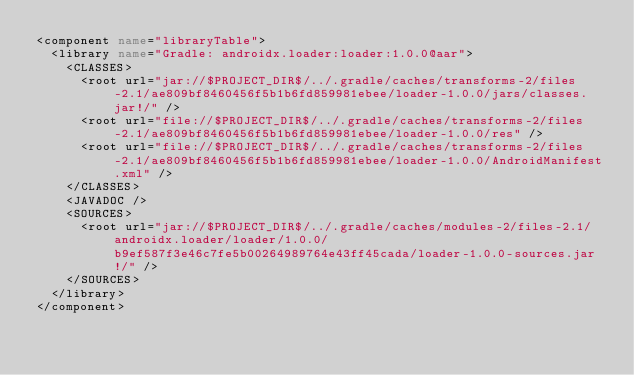Convert code to text. <code><loc_0><loc_0><loc_500><loc_500><_XML_><component name="libraryTable">
  <library name="Gradle: androidx.loader:loader:1.0.0@aar">
    <CLASSES>
      <root url="jar://$PROJECT_DIR$/../.gradle/caches/transforms-2/files-2.1/ae809bf8460456f5b1b6fd859981ebee/loader-1.0.0/jars/classes.jar!/" />
      <root url="file://$PROJECT_DIR$/../.gradle/caches/transforms-2/files-2.1/ae809bf8460456f5b1b6fd859981ebee/loader-1.0.0/res" />
      <root url="file://$PROJECT_DIR$/../.gradle/caches/transforms-2/files-2.1/ae809bf8460456f5b1b6fd859981ebee/loader-1.0.0/AndroidManifest.xml" />
    </CLASSES>
    <JAVADOC />
    <SOURCES>
      <root url="jar://$PROJECT_DIR$/../.gradle/caches/modules-2/files-2.1/androidx.loader/loader/1.0.0/b9ef587f3e46c7fe5b00264989764e43ff45cada/loader-1.0.0-sources.jar!/" />
    </SOURCES>
  </library>
</component></code> 